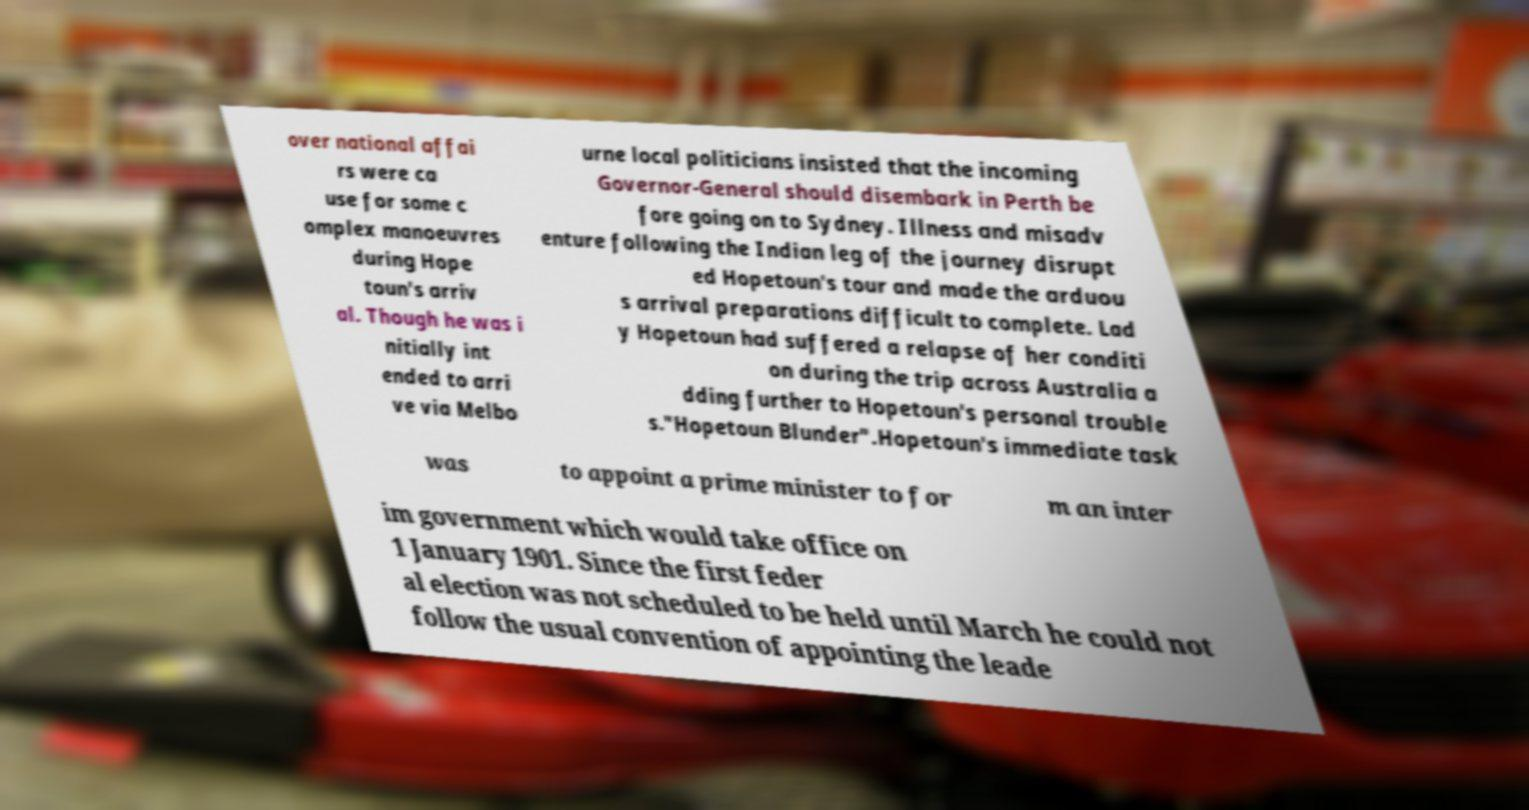Can you read and provide the text displayed in the image?This photo seems to have some interesting text. Can you extract and type it out for me? over national affai rs were ca use for some c omplex manoeuvres during Hope toun's arriv al. Though he was i nitially int ended to arri ve via Melbo urne local politicians insisted that the incoming Governor-General should disembark in Perth be fore going on to Sydney. Illness and misadv enture following the Indian leg of the journey disrupt ed Hopetoun's tour and made the arduou s arrival preparations difficult to complete. Lad y Hopetoun had suffered a relapse of her conditi on during the trip across Australia a dding further to Hopetoun's personal trouble s."Hopetoun Blunder".Hopetoun's immediate task was to appoint a prime minister to for m an inter im government which would take office on 1 January 1901. Since the first feder al election was not scheduled to be held until March he could not follow the usual convention of appointing the leade 